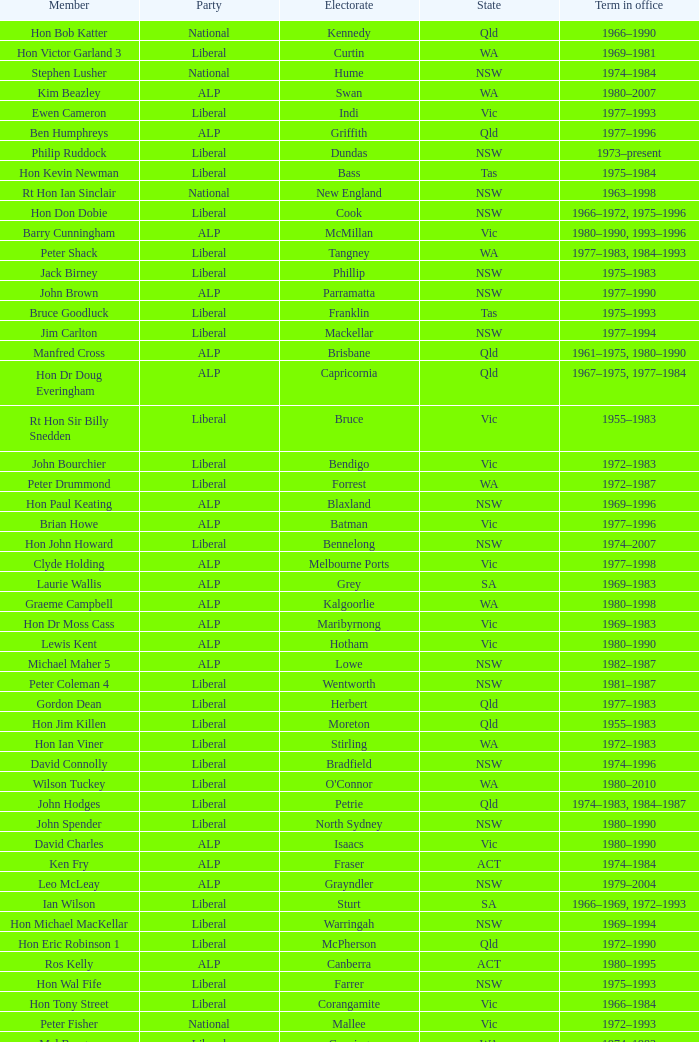Which party had a member from the state of Vic and an Electorate called Wannon? Liberal. 